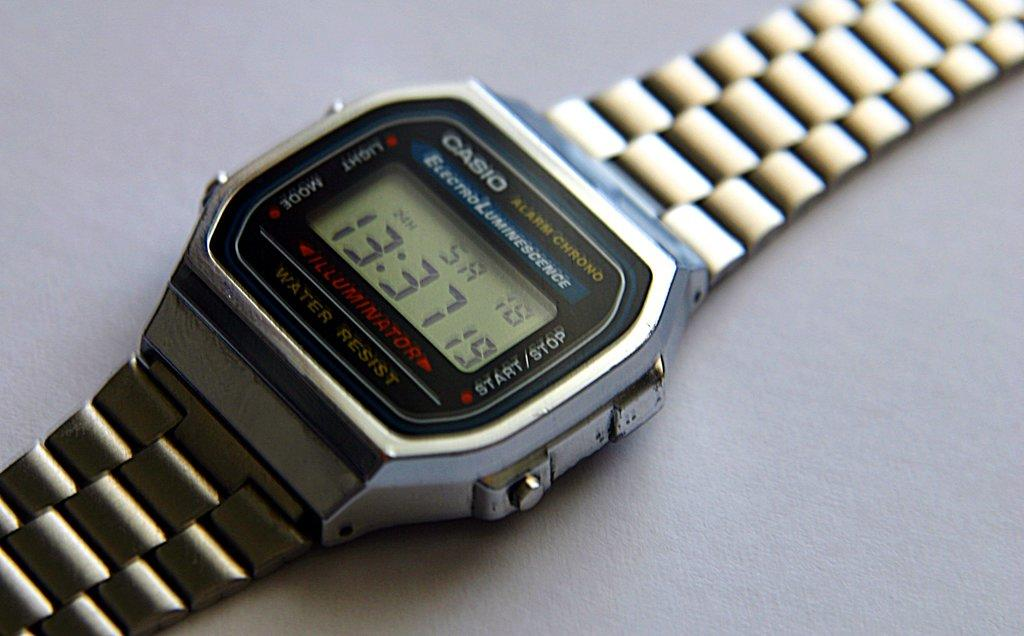<image>
Describe the image concisely. The Casio watch shows the time as 13:37. 